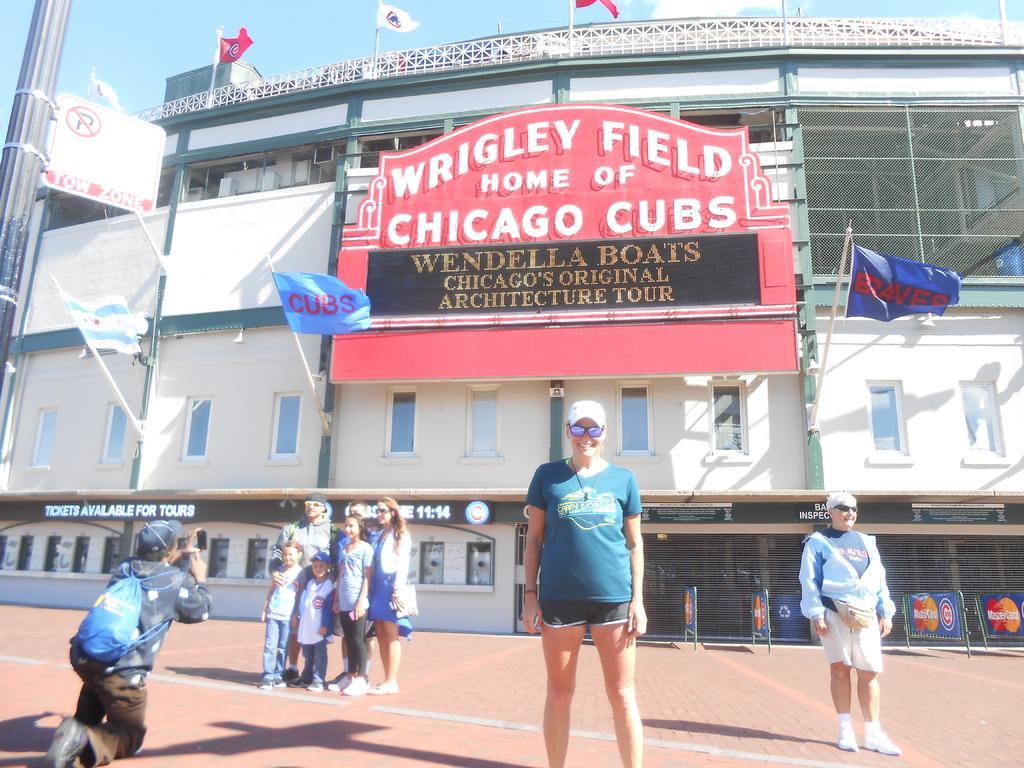Describe this image in one or two sentences. In this image we can see a few people standing in front of the building, a person is clicking picture, there are flags attached to the building and text written om the building, there are few boards, a pole with sign board and sky in the background. 